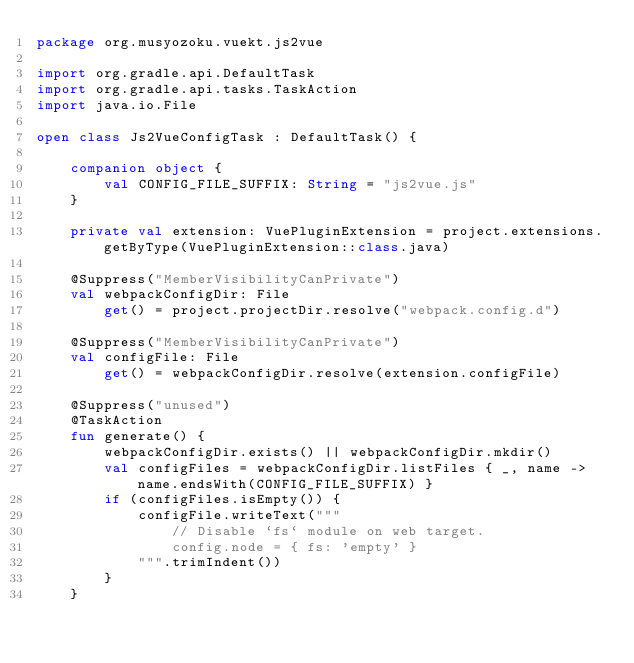<code> <loc_0><loc_0><loc_500><loc_500><_Kotlin_>package org.musyozoku.vuekt.js2vue

import org.gradle.api.DefaultTask
import org.gradle.api.tasks.TaskAction
import java.io.File

open class Js2VueConfigTask : DefaultTask() {

    companion object {
        val CONFIG_FILE_SUFFIX: String = "js2vue.js"
    }

    private val extension: VuePluginExtension = project.extensions.getByType(VuePluginExtension::class.java)

    @Suppress("MemberVisibilityCanPrivate")
    val webpackConfigDir: File
        get() = project.projectDir.resolve("webpack.config.d")

    @Suppress("MemberVisibilityCanPrivate")
    val configFile: File
        get() = webpackConfigDir.resolve(extension.configFile)

    @Suppress("unused")
    @TaskAction
    fun generate() {
        webpackConfigDir.exists() || webpackConfigDir.mkdir()
        val configFiles = webpackConfigDir.listFiles { _, name ->  name.endsWith(CONFIG_FILE_SUFFIX) }
        if (configFiles.isEmpty()) {
            configFile.writeText("""
                // Disable `fs` module on web target.
                config.node = { fs: 'empty' }
            """.trimIndent())
        }
    }</code> 